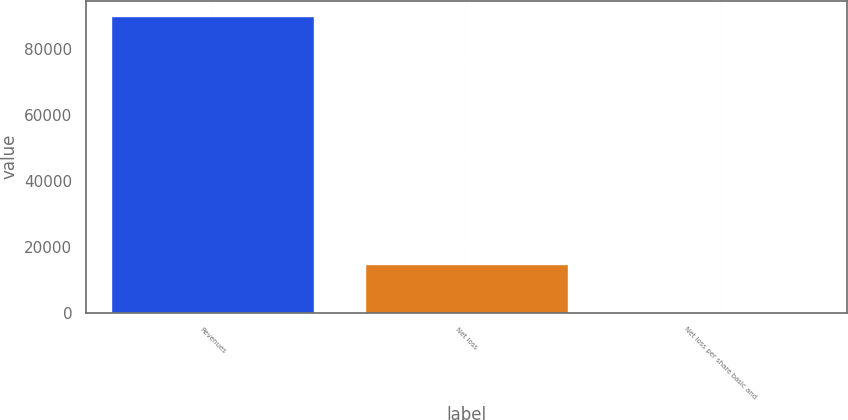<chart> <loc_0><loc_0><loc_500><loc_500><bar_chart><fcel>Revenues<fcel>Net loss<fcel>Net loss per share basic and<nl><fcel>90032<fcel>14938<fcel>0.19<nl></chart> 